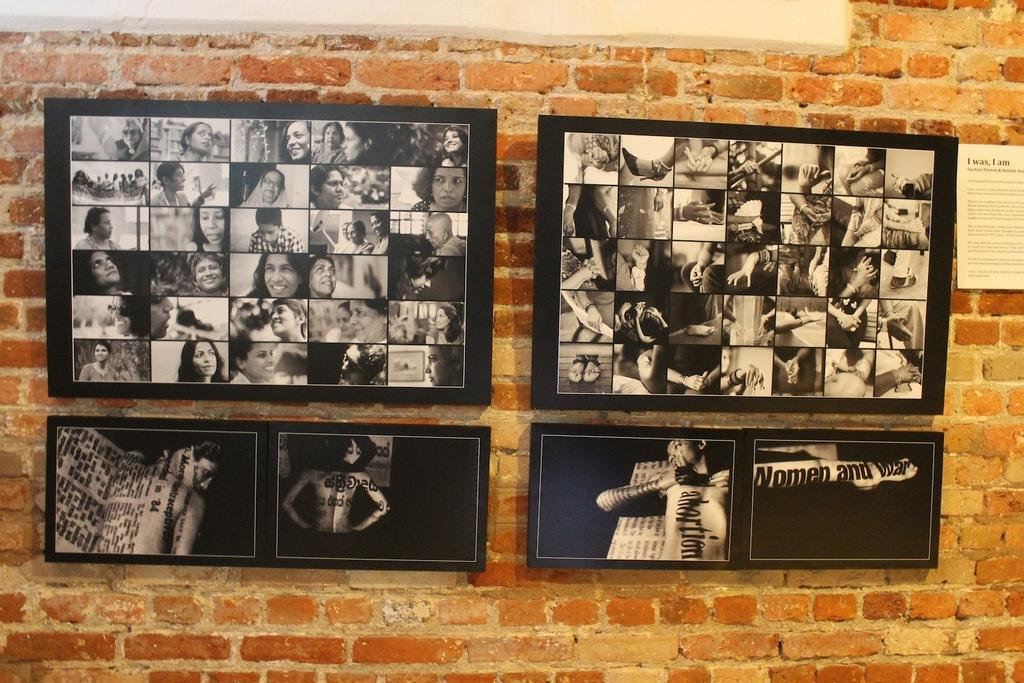What can be seen hanging on the wall in the image? There are frames on the wall in the image. What else is present in the image besides the frames on the wall? There is a paper in the image. What type of humor can be found in the paper in the image? There is no humor present in the paper in the image, as the facts provided do not mention any content or context for the paper. 